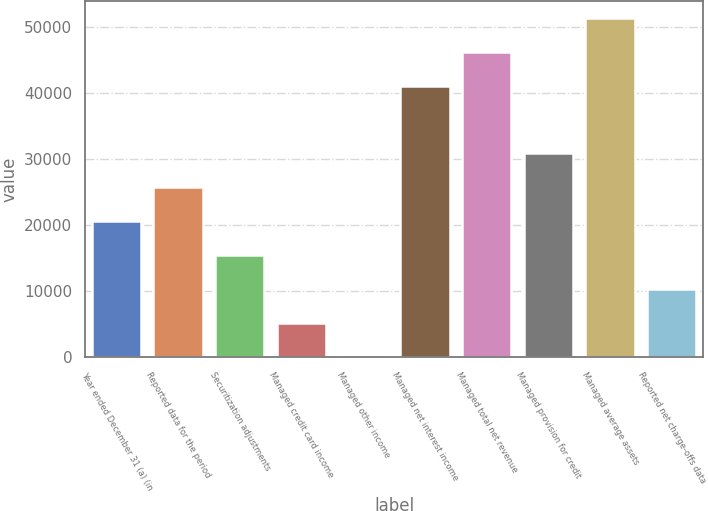<chart> <loc_0><loc_0><loc_500><loc_500><bar_chart><fcel>Year ended December 31 (a) (in<fcel>Reported data for the period<fcel>Securitization adjustments<fcel>Managed credit card income<fcel>Managed other income<fcel>Managed net interest income<fcel>Managed total net revenue<fcel>Managed provision for credit<fcel>Managed average assets<fcel>Reported net charge-offs data<nl><fcel>20594.8<fcel>25730<fcel>15459.6<fcel>5189.2<fcel>54<fcel>41135.6<fcel>46270.8<fcel>30865.2<fcel>51406<fcel>10324.4<nl></chart> 